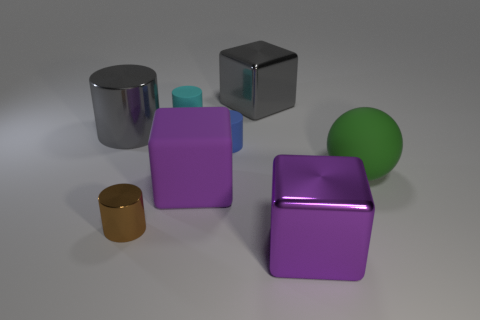Subtract all blue cylinders. How many cylinders are left? 3 Add 1 gray cylinders. How many objects exist? 9 Subtract all red cylinders. Subtract all green balls. How many cylinders are left? 4 Subtract all spheres. How many objects are left? 7 Add 6 small brown metallic things. How many small brown metallic things are left? 7 Add 6 large green matte objects. How many large green matte objects exist? 7 Subtract 1 cyan cylinders. How many objects are left? 7 Subtract all small cyan rubber cylinders. Subtract all matte cubes. How many objects are left? 6 